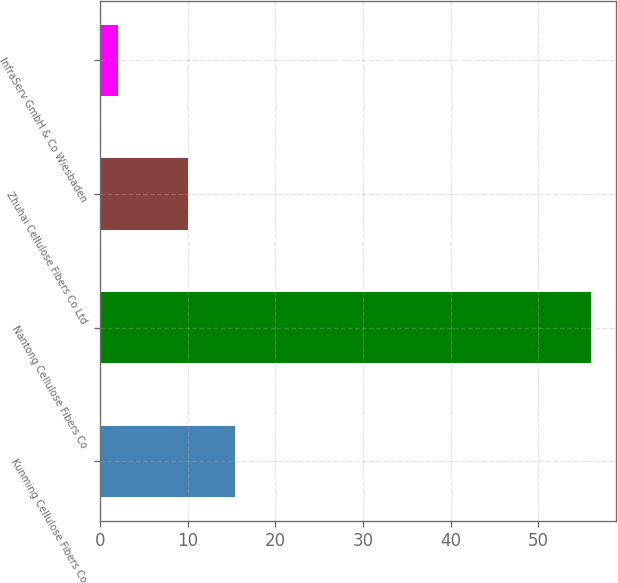<chart> <loc_0><loc_0><loc_500><loc_500><bar_chart><fcel>Kunming Cellulose Fibers Co<fcel>Nantong Cellulose Fibers Co<fcel>Zhuhai Cellulose Fibers Co Ltd<fcel>InfraServ GmbH & Co Wiesbaden<nl><fcel>15.4<fcel>56<fcel>10<fcel>2<nl></chart> 